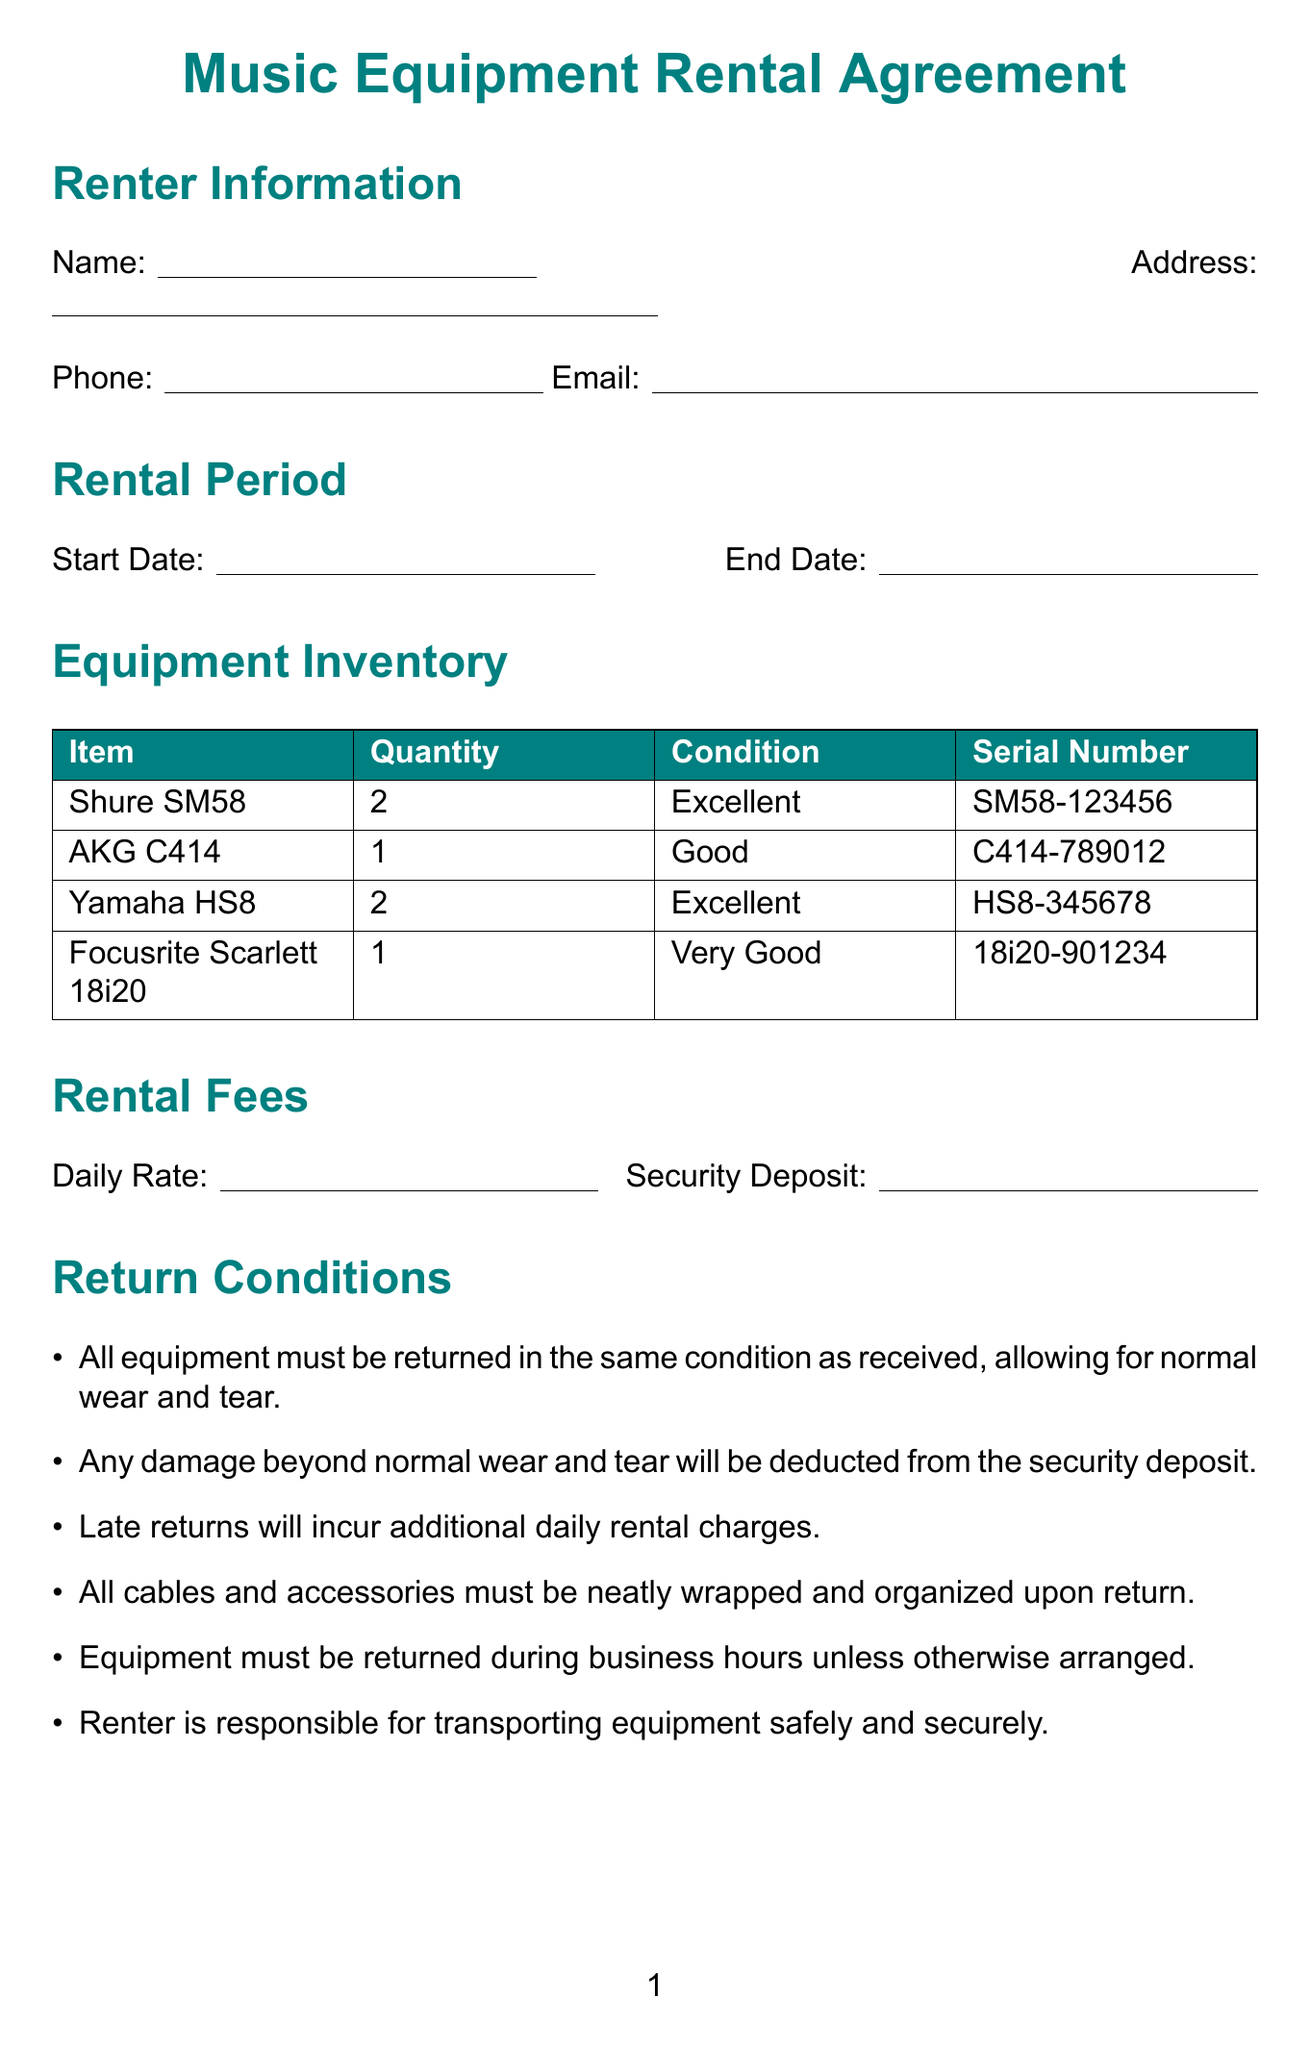what is the title of the agreement? The title of the agreement is found at the top of the document, which is "Music Equipment Rental Agreement."
Answer: Music Equipment Rental Agreement who is responsible for transporting the equipment? The document specifies that the renter is responsible for transporting equipment safely and securely during the rental period.
Answer: Renter what is the security deposit amount? The document states the security deposit in the "Rental Fees" section. It simply says "Security Deposit Amount."
Answer: Security Deposit Amount how many microphones are included in the inventory? The inventory lists 2 Shure SM58 microphones and 1 AKG C414 microphone, totaling 3 microphones.
Answer: 3 when do late returns incur additional charges? The return conditions specify that late returns will incur additional daily rental charges, indicating a specific timeframe for penalties after the agreed return date.
Answer: Additional daily rental charges can the equipment be sublet? The usage guidelines clearly state that equipment may not be sublet, making it restricted for rental purposes.
Answer: No what happens if the equipment is damaged? The return conditions explain that any damage beyond normal wear and tear will be deducted from the security deposit, outlining the renter's financial responsibility.
Answer: Deducted from the security deposit what is the cancellation policy for this rental? The document outlines that cancellations made within 24 hours of the rental start time will incur a specific percentage of the total rental fee as a charge.
Answer: 50% charge what is the condition of the Yamaha HS8 studio monitors? In the inventory section, it is stated that the Yamaha HS8 monitors are in "Excellent" condition.
Answer: Excellent 